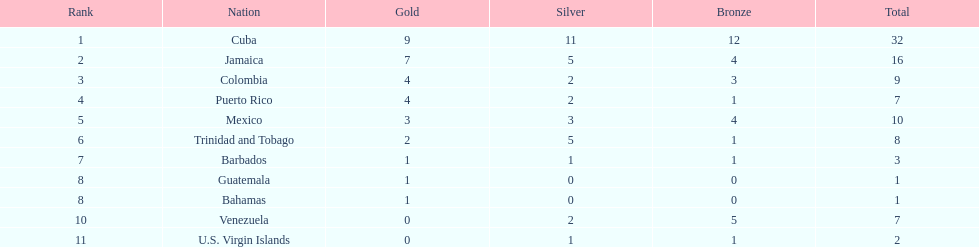Which country obtained more than five silver medals? Cuba. 